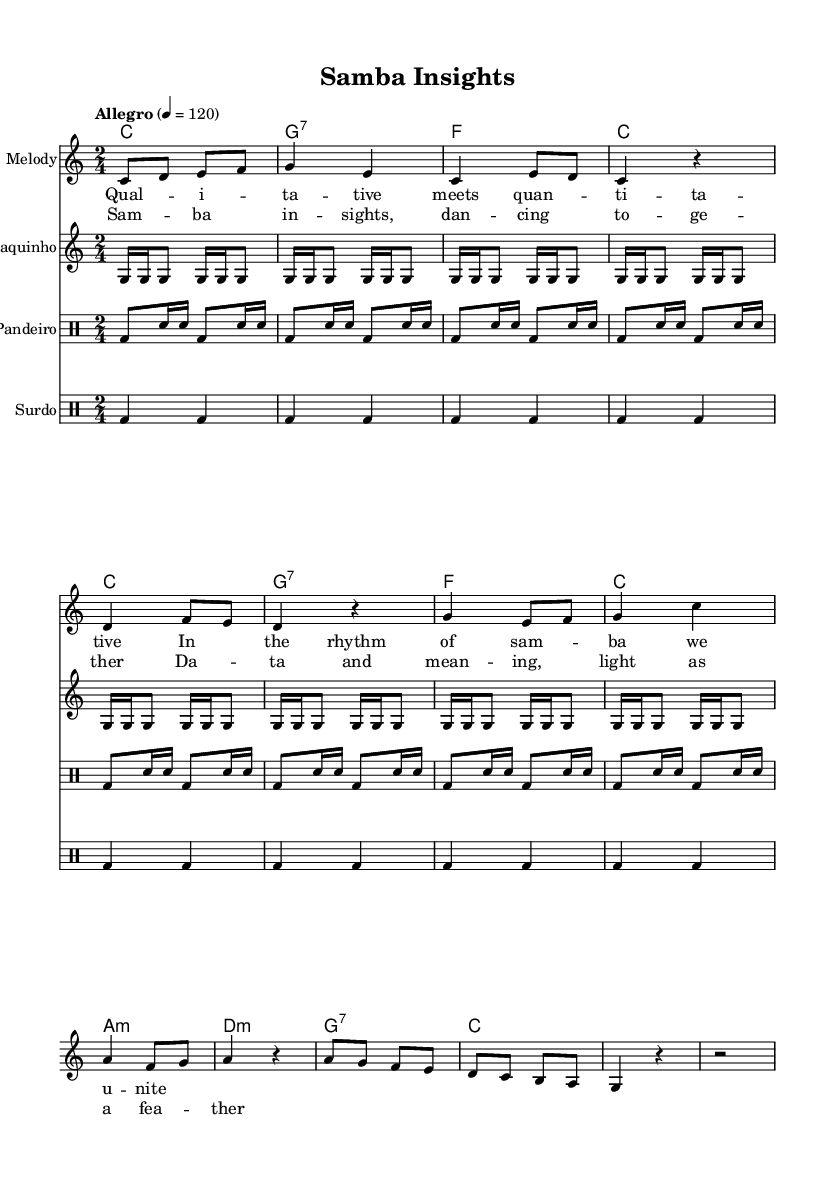What is the key signature of this music? The key signature is C major, which has no sharps or flats indicated in the music sheet.
Answer: C major What is the time signature of the piece? The time signature of the piece is found at the beginning of the music and is indicated as 2/4, meaning there are two beats in a measure.
Answer: 2/4 What is the tempo marking for this piece? The tempo marking is noted at the start as "Allegro," which indicates a fast tempo. The beats per minute (BPM) is also specified as 120.
Answer: Allegro How many measures are in the chorus section? To determine the number of measures, count the distinct sets of bars in the chorus part, which consists of 4 measures in total.
Answer: 4 What emotional characteristics might indicate its samba influence? The genre characteristics of samba include lively rhythms and a danceable quality, which can be deduced from the use of syncopated patterns in the drums and a joyful melodic phrase in the vocals.
Answer: Lively What instruments are featured in the arrangement? The arrangement features a melody instrument, cavaquinho, pandeiro, and surdo, as indicated in the music score layout under their respective staff titles.
Answer: Cavaquinho, pandeiro, and surdo What is the theme expressed in the lyrics of the verse? The theme in this verse connects qualitative insights with quantitative data through samba, highlighting the unity of these concepts through dance and rhythm.
Answer: Qualitative meets quantitative 